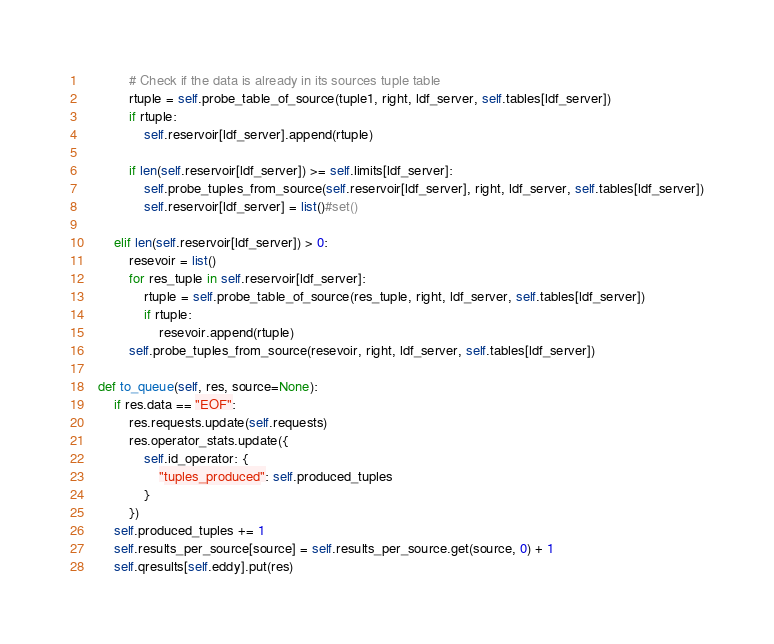<code> <loc_0><loc_0><loc_500><loc_500><_Python_>
            # Check if the data is already in its sources tuple table
            rtuple = self.probe_table_of_source(tuple1, right, ldf_server, self.tables[ldf_server])
            if rtuple:
                self.reservoir[ldf_server].append(rtuple)

            if len(self.reservoir[ldf_server]) >= self.limits[ldf_server]:
                self.probe_tuples_from_source(self.reservoir[ldf_server], right, ldf_server, self.tables[ldf_server])
                self.reservoir[ldf_server] = list()#set()

        elif len(self.reservoir[ldf_server]) > 0:
            resevoir = list()
            for res_tuple in self.reservoir[ldf_server]:
                rtuple = self.probe_table_of_source(res_tuple, right, ldf_server, self.tables[ldf_server])
                if rtuple:
                    resevoir.append(rtuple)
            self.probe_tuples_from_source(resevoir, right, ldf_server, self.tables[ldf_server])

    def to_queue(self, res, source=None):
        if res.data == "EOF":
            res.requests.update(self.requests)
            res.operator_stats.update({
                self.id_operator: {
                    "tuples_produced": self.produced_tuples
                }
            })
        self.produced_tuples += 1
        self.results_per_source[source] = self.results_per_source.get(source, 0) + 1
        self.qresults[self.eddy].put(res)

</code> 